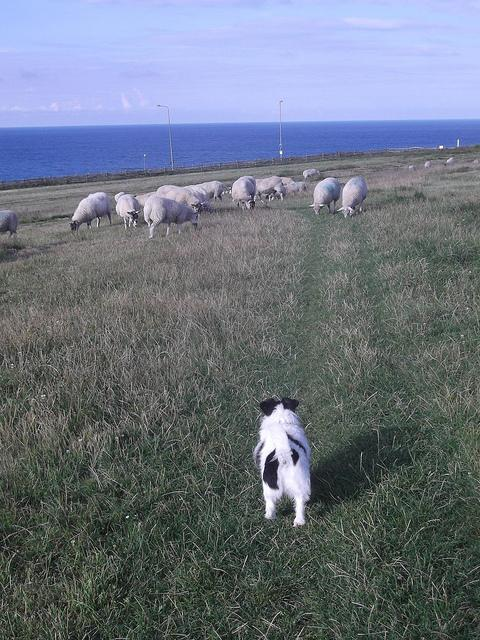What animal is facing the herd?

Choices:
A) rabbit
B) cat
C) fox
D) dog dog 